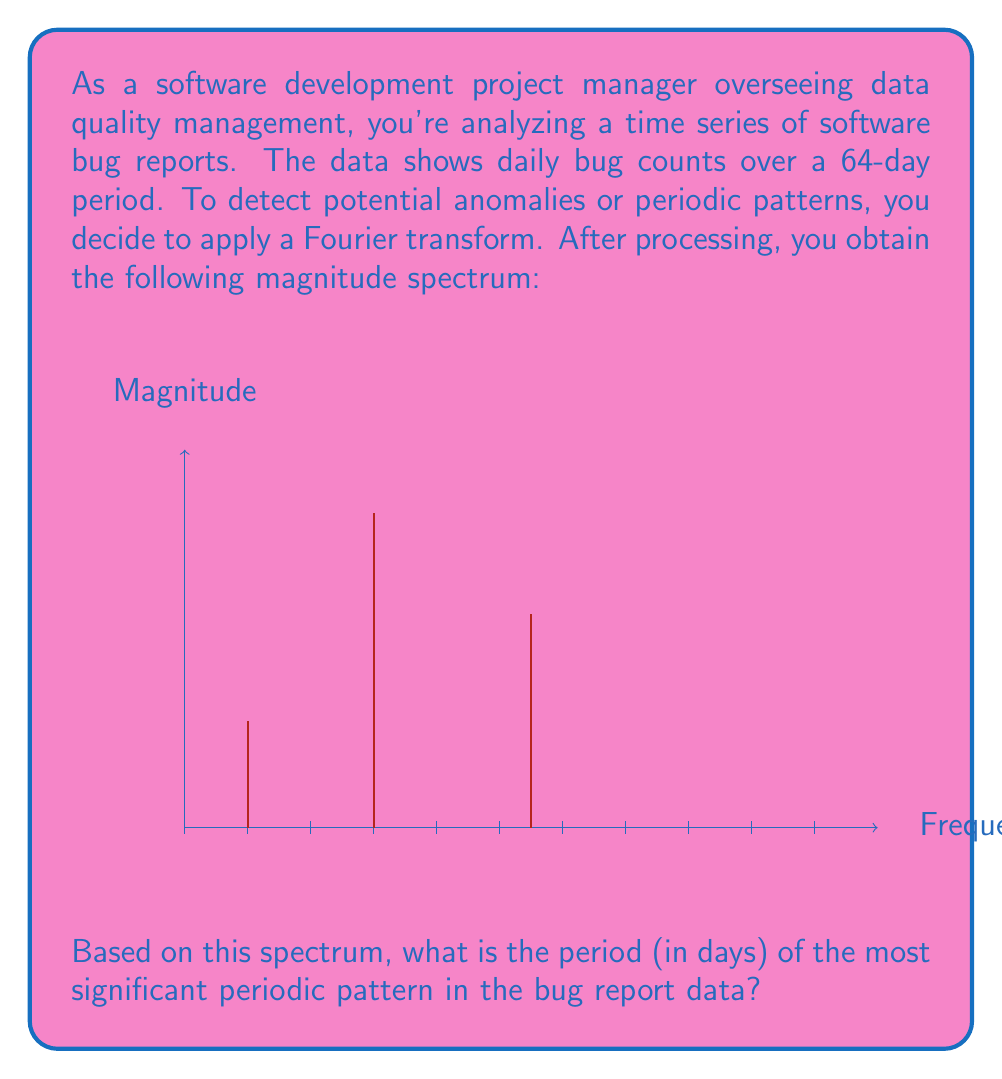Can you solve this math problem? To solve this problem, we need to interpret the Fourier transform results:

1) In the Fourier transform, each frequency component corresponds to a periodic pattern in the original time series.

2) The magnitude of each frequency component represents its significance in the original data.

3) The x-axis represents frequency, where each unit corresponds to 1 cycle per 64 days (as we have 64 days of data).

4) The most significant peak in the spectrum occurs at the 8th frequency component (counting from 0).

5) To calculate the period, we use the formula:

   $$T = \frac{N}{k}$$

   Where:
   $T$ = period
   $N$ = total number of days (64)
   $k$ = frequency component number (8)

6) Substituting the values:

   $$T = \frac{64}{8} = 8$$

Therefore, the most significant periodic pattern in the bug report data has a period of 8 days.
Answer: 8 days 